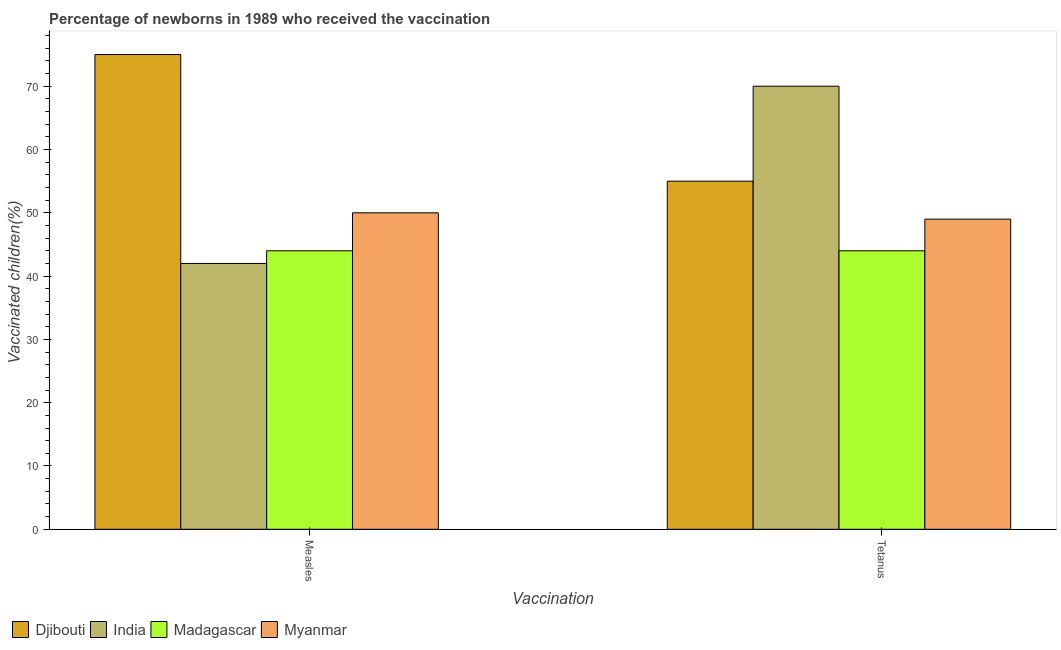Are the number of bars per tick equal to the number of legend labels?
Provide a succinct answer. Yes. Are the number of bars on each tick of the X-axis equal?
Make the answer very short. Yes. How many bars are there on the 1st tick from the left?
Provide a short and direct response. 4. What is the label of the 2nd group of bars from the left?
Your answer should be compact. Tetanus. What is the percentage of newborns who received vaccination for measles in Madagascar?
Your answer should be compact. 44. Across all countries, what is the maximum percentage of newborns who received vaccination for tetanus?
Your answer should be compact. 70. Across all countries, what is the minimum percentage of newborns who received vaccination for tetanus?
Your answer should be compact. 44. In which country was the percentage of newborns who received vaccination for tetanus maximum?
Your answer should be compact. India. In which country was the percentage of newborns who received vaccination for tetanus minimum?
Offer a terse response. Madagascar. What is the total percentage of newborns who received vaccination for tetanus in the graph?
Your answer should be very brief. 218. What is the difference between the percentage of newborns who received vaccination for measles in Myanmar and that in Madagascar?
Provide a short and direct response. 6. What is the difference between the percentage of newborns who received vaccination for measles in Djibouti and the percentage of newborns who received vaccination for tetanus in Madagascar?
Your answer should be compact. 31. What is the average percentage of newborns who received vaccination for tetanus per country?
Ensure brevity in your answer.  54.5. What is the difference between the percentage of newborns who received vaccination for measles and percentage of newborns who received vaccination for tetanus in Djibouti?
Provide a succinct answer. 20. In how many countries, is the percentage of newborns who received vaccination for tetanus greater than 8 %?
Your answer should be compact. 4. Is the percentage of newborns who received vaccination for tetanus in Myanmar less than that in Madagascar?
Give a very brief answer. No. What does the 3rd bar from the left in Tetanus represents?
Make the answer very short. Madagascar. What does the 2nd bar from the right in Measles represents?
Provide a short and direct response. Madagascar. How many bars are there?
Provide a short and direct response. 8. How many countries are there in the graph?
Offer a terse response. 4. What is the difference between two consecutive major ticks on the Y-axis?
Make the answer very short. 10. Does the graph contain any zero values?
Your answer should be compact. No. Where does the legend appear in the graph?
Keep it short and to the point. Bottom left. How are the legend labels stacked?
Offer a terse response. Horizontal. What is the title of the graph?
Keep it short and to the point. Percentage of newborns in 1989 who received the vaccination. Does "Guinea-Bissau" appear as one of the legend labels in the graph?
Your response must be concise. No. What is the label or title of the X-axis?
Offer a terse response. Vaccination. What is the label or title of the Y-axis?
Offer a very short reply. Vaccinated children(%)
. What is the Vaccinated children(%)
 in Djibouti in Measles?
Offer a terse response. 75. What is the Vaccinated children(%)
 in Myanmar in Measles?
Provide a short and direct response. 50. What is the Vaccinated children(%)
 in Djibouti in Tetanus?
Offer a very short reply. 55. What is the Vaccinated children(%)
 of India in Tetanus?
Keep it short and to the point. 70. What is the Vaccinated children(%)
 in Myanmar in Tetanus?
Keep it short and to the point. 49. Across all Vaccination, what is the maximum Vaccinated children(%)
 in Madagascar?
Offer a terse response. 44. Across all Vaccination, what is the minimum Vaccinated children(%)
 in India?
Provide a short and direct response. 42. Across all Vaccination, what is the minimum Vaccinated children(%)
 of Myanmar?
Make the answer very short. 49. What is the total Vaccinated children(%)
 in Djibouti in the graph?
Give a very brief answer. 130. What is the total Vaccinated children(%)
 in India in the graph?
Ensure brevity in your answer.  112. What is the total Vaccinated children(%)
 of Madagascar in the graph?
Offer a terse response. 88. What is the difference between the Vaccinated children(%)
 in Djibouti in Measles and that in Tetanus?
Give a very brief answer. 20. What is the difference between the Vaccinated children(%)
 in India in Measles and that in Tetanus?
Offer a very short reply. -28. What is the difference between the Vaccinated children(%)
 in Myanmar in Measles and that in Tetanus?
Give a very brief answer. 1. What is the difference between the Vaccinated children(%)
 in Djibouti in Measles and the Vaccinated children(%)
 in India in Tetanus?
Ensure brevity in your answer.  5. What is the average Vaccinated children(%)
 of Djibouti per Vaccination?
Offer a terse response. 65. What is the average Vaccinated children(%)
 in Madagascar per Vaccination?
Make the answer very short. 44. What is the average Vaccinated children(%)
 in Myanmar per Vaccination?
Keep it short and to the point. 49.5. What is the difference between the Vaccinated children(%)
 in Djibouti and Vaccinated children(%)
 in Myanmar in Measles?
Your response must be concise. 25. What is the difference between the Vaccinated children(%)
 of India and Vaccinated children(%)
 of Madagascar in Measles?
Make the answer very short. -2. What is the difference between the Vaccinated children(%)
 in Madagascar and Vaccinated children(%)
 in Myanmar in Measles?
Offer a very short reply. -6. What is the difference between the Vaccinated children(%)
 of Djibouti and Vaccinated children(%)
 of India in Tetanus?
Offer a very short reply. -15. What is the difference between the Vaccinated children(%)
 of Djibouti and Vaccinated children(%)
 of Myanmar in Tetanus?
Make the answer very short. 6. What is the difference between the Vaccinated children(%)
 in India and Vaccinated children(%)
 in Madagascar in Tetanus?
Offer a terse response. 26. What is the ratio of the Vaccinated children(%)
 of Djibouti in Measles to that in Tetanus?
Give a very brief answer. 1.36. What is the ratio of the Vaccinated children(%)
 of India in Measles to that in Tetanus?
Provide a short and direct response. 0.6. What is the ratio of the Vaccinated children(%)
 in Madagascar in Measles to that in Tetanus?
Your answer should be very brief. 1. What is the ratio of the Vaccinated children(%)
 of Myanmar in Measles to that in Tetanus?
Ensure brevity in your answer.  1.02. What is the difference between the highest and the second highest Vaccinated children(%)
 in Myanmar?
Ensure brevity in your answer.  1. What is the difference between the highest and the lowest Vaccinated children(%)
 in Djibouti?
Your answer should be very brief. 20. What is the difference between the highest and the lowest Vaccinated children(%)
 in India?
Offer a terse response. 28. What is the difference between the highest and the lowest Vaccinated children(%)
 of Madagascar?
Provide a short and direct response. 0. 